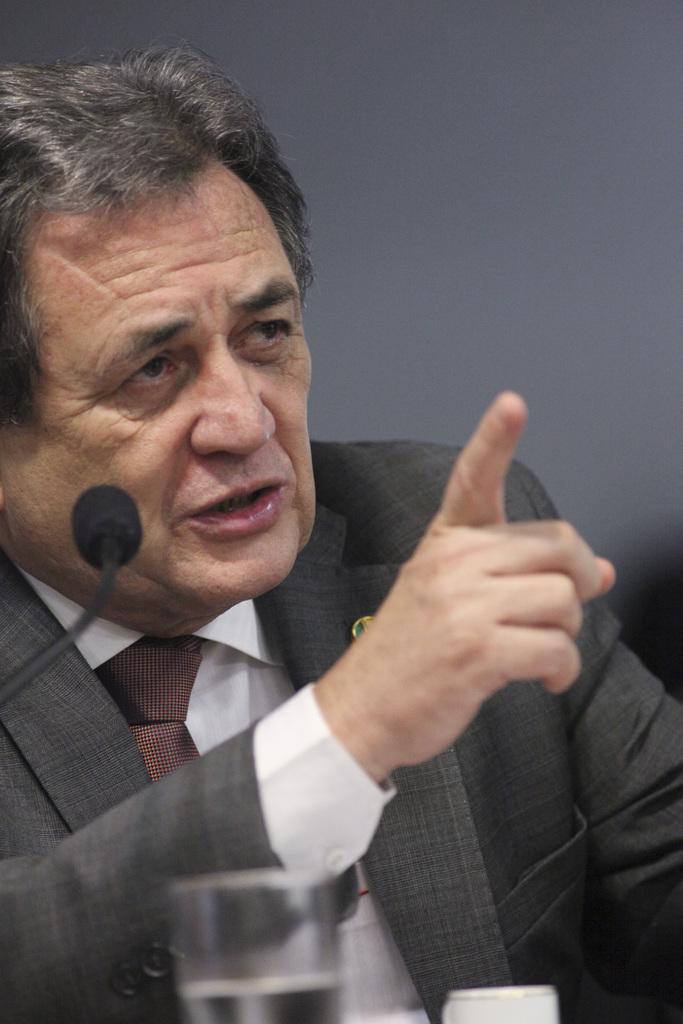Please provide a concise description of this image. In this image we can see one man in a suit sitting near the microphone and talking. There is one small batch attached to the man suit, one black object on the right side of the image, there is a white wall in the background, the background is blurred, one glass with water and one white cup on the bottom of the image. 